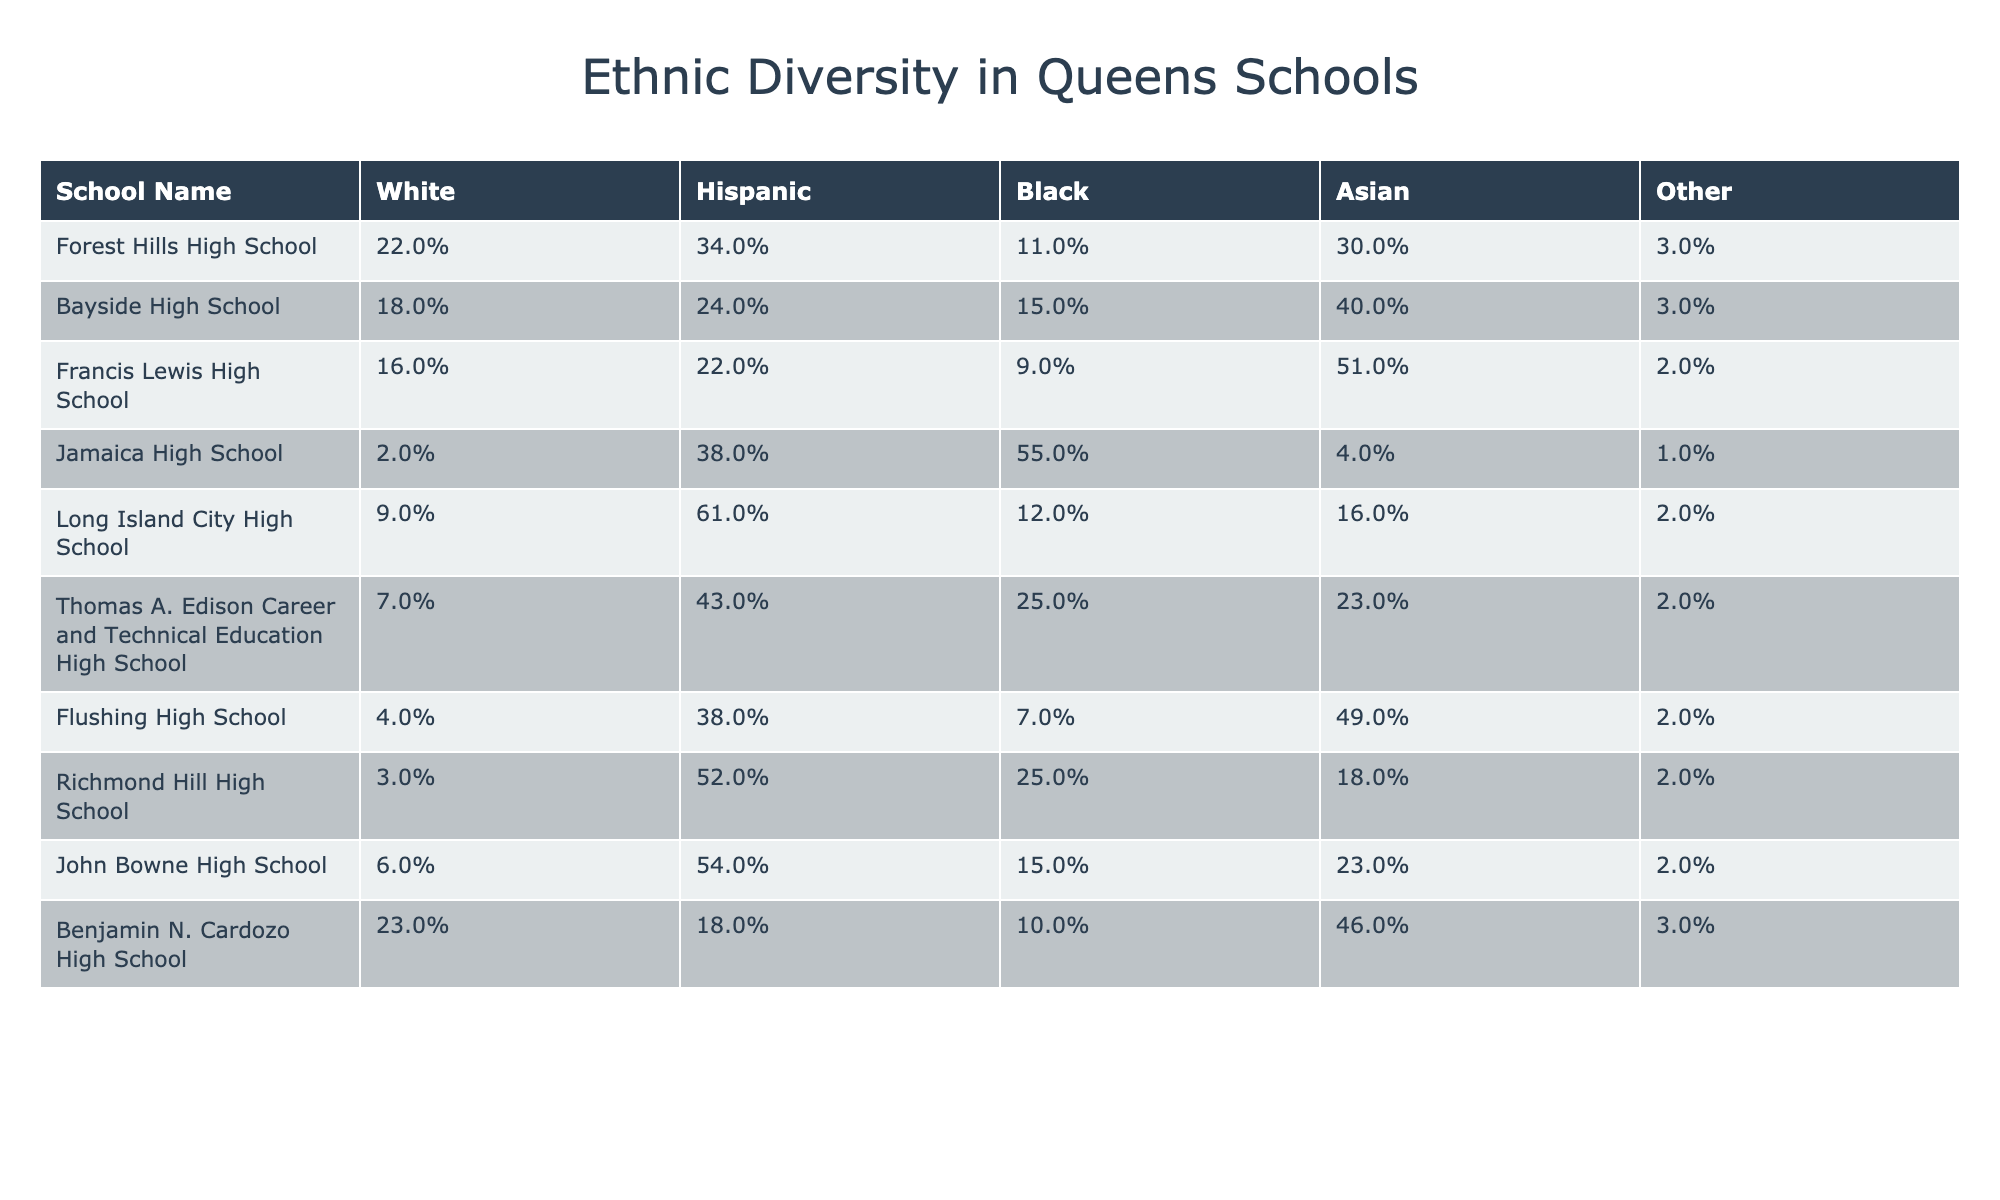What is the Black percentage in Jamaica High School? The table shows Jamaica High School has a Black percentage of 55%. The value is directly listed in the corresponding row and column for this school.
Answer: 55% Which school has the highest Asian percentage? By reviewing each school's Asian percentage, Long Island City High School has the highest percentage at 16%. This is determined by comparing all the values in the Asian column across schools.
Answer: 16% What is the average Hispanic percentage across all schools? The Hispanic percentages are: 34, 24, 22, 38, 61, 43, 38, 52, 54, and 18. Adding them gives a total of 392. There are 10 schools, so the average is 392 divided by 10, which equals 39.2%.
Answer: 39.2% Does Benjamin N. Cardozo High School have more than 20% of White students? According to the table, Benjamin N. Cardozo High School has a White percentage of 23%. Since 23% is greater than 20%, the statement is true.
Answer: Yes Which schools have more than 50% Hispanic students? Checking the Hispanic percentages, Long Island City High School (61%) and Richmond Hill High School (52%) have more than 50% Hispanic students. This involves reviewing the percentages directly in the Hispanic column for each school.
Answer: Long Island City High School, Richmond Hill High School What is the difference between the highest and lowest White percentages? Forest Hills High School has the highest White percentage at 22%, while Jamaica High School has the lowest at 2%. The difference is calculated by subtracting the lowest from the highest: 22% - 2% = 20%.
Answer: 20% 